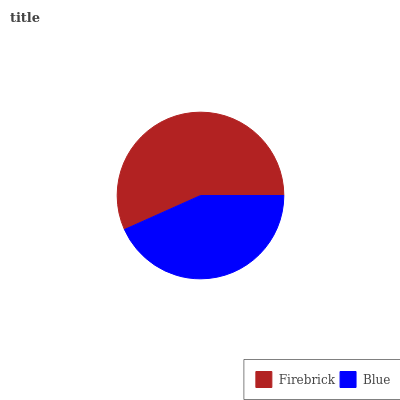Is Blue the minimum?
Answer yes or no. Yes. Is Firebrick the maximum?
Answer yes or no. Yes. Is Blue the maximum?
Answer yes or no. No. Is Firebrick greater than Blue?
Answer yes or no. Yes. Is Blue less than Firebrick?
Answer yes or no. Yes. Is Blue greater than Firebrick?
Answer yes or no. No. Is Firebrick less than Blue?
Answer yes or no. No. Is Firebrick the high median?
Answer yes or no. Yes. Is Blue the low median?
Answer yes or no. Yes. Is Blue the high median?
Answer yes or no. No. Is Firebrick the low median?
Answer yes or no. No. 